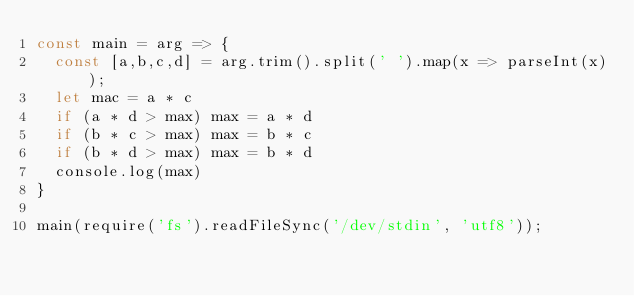<code> <loc_0><loc_0><loc_500><loc_500><_JavaScript_>const main = arg => {
  const [a,b,c,d] = arg.trim().split(' ').map(x => parseInt(x));
  let mac = a * c
  if (a * d > max) max = a * d
  if (b * c > max) max = b * c
  if (b * d > max) max = b * d
  console.log(max)
}

main(require('fs').readFileSync('/dev/stdin', 'utf8'));</code> 